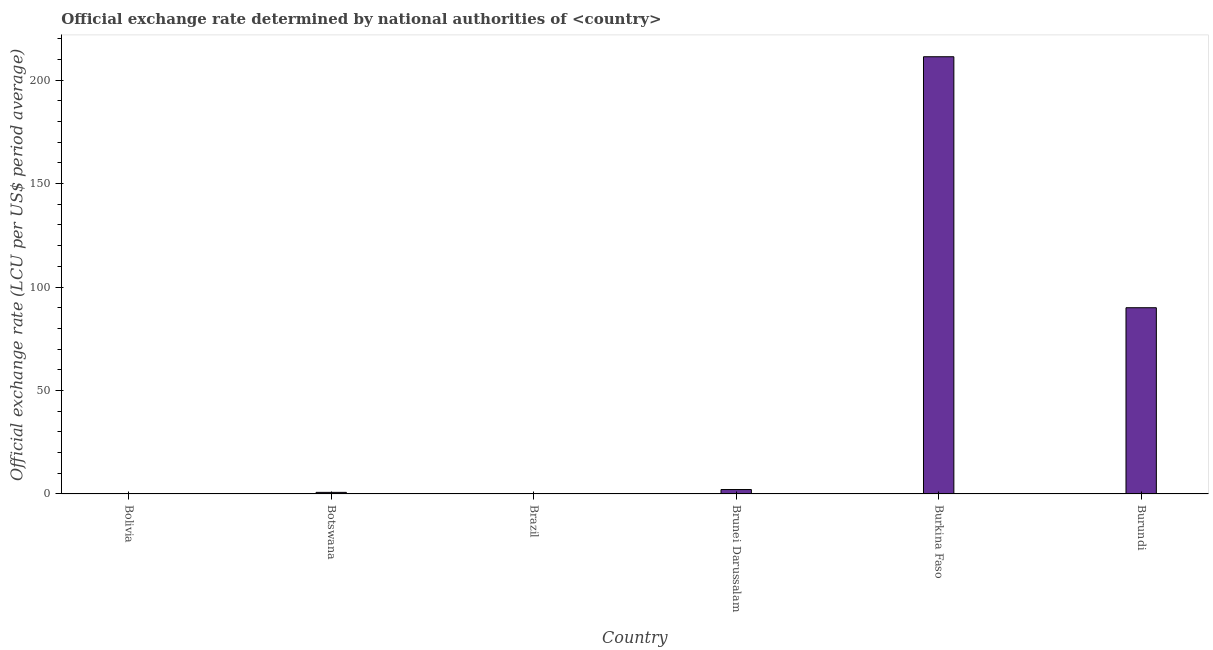Does the graph contain any zero values?
Ensure brevity in your answer.  No. Does the graph contain grids?
Your answer should be very brief. No. What is the title of the graph?
Ensure brevity in your answer.  Official exchange rate determined by national authorities of <country>. What is the label or title of the X-axis?
Provide a short and direct response. Country. What is the label or title of the Y-axis?
Your answer should be very brief. Official exchange rate (LCU per US$ period average). What is the official exchange rate in Brunei Darussalam?
Provide a succinct answer. 2.14. Across all countries, what is the maximum official exchange rate?
Your answer should be very brief. 211.28. Across all countries, what is the minimum official exchange rate?
Offer a very short reply. 2.28123189244443e-11. In which country was the official exchange rate maximum?
Provide a short and direct response. Burkina Faso. In which country was the official exchange rate minimum?
Your answer should be very brief. Brazil. What is the sum of the official exchange rate?
Offer a terse response. 304.2. What is the difference between the official exchange rate in Bolivia and Brunei Darussalam?
Your answer should be compact. -2.14. What is the average official exchange rate per country?
Your answer should be compact. 50.7. What is the median official exchange rate?
Your answer should be very brief. 1.46. In how many countries, is the official exchange rate greater than 140 ?
Your answer should be very brief. 1. What is the ratio of the official exchange rate in Burkina Faso to that in Burundi?
Your response must be concise. 2.35. What is the difference between the highest and the second highest official exchange rate?
Offer a very short reply. 121.28. Is the sum of the official exchange rate in Bolivia and Brunei Darussalam greater than the maximum official exchange rate across all countries?
Provide a succinct answer. No. What is the difference between the highest and the lowest official exchange rate?
Your answer should be very brief. 211.28. In how many countries, is the official exchange rate greater than the average official exchange rate taken over all countries?
Offer a terse response. 2. What is the Official exchange rate (LCU per US$ period average) of Bolivia?
Ensure brevity in your answer.  2.452e-5. What is the Official exchange rate (LCU per US$ period average) of Botswana?
Provide a short and direct response. 0.78. What is the Official exchange rate (LCU per US$ period average) in Brazil?
Offer a terse response. 2.28123189244443e-11. What is the Official exchange rate (LCU per US$ period average) in Brunei Darussalam?
Provide a short and direct response. 2.14. What is the Official exchange rate (LCU per US$ period average) of Burkina Faso?
Keep it short and to the point. 211.28. What is the difference between the Official exchange rate (LCU per US$ period average) in Bolivia and Botswana?
Your response must be concise. -0.78. What is the difference between the Official exchange rate (LCU per US$ period average) in Bolivia and Brazil?
Give a very brief answer. 2e-5. What is the difference between the Official exchange rate (LCU per US$ period average) in Bolivia and Brunei Darussalam?
Make the answer very short. -2.14. What is the difference between the Official exchange rate (LCU per US$ period average) in Bolivia and Burkina Faso?
Your response must be concise. -211.28. What is the difference between the Official exchange rate (LCU per US$ period average) in Bolivia and Burundi?
Provide a succinct answer. -90. What is the difference between the Official exchange rate (LCU per US$ period average) in Botswana and Brazil?
Offer a very short reply. 0.78. What is the difference between the Official exchange rate (LCU per US$ period average) in Botswana and Brunei Darussalam?
Offer a terse response. -1.36. What is the difference between the Official exchange rate (LCU per US$ period average) in Botswana and Burkina Faso?
Offer a very short reply. -210.5. What is the difference between the Official exchange rate (LCU per US$ period average) in Botswana and Burundi?
Give a very brief answer. -89.22. What is the difference between the Official exchange rate (LCU per US$ period average) in Brazil and Brunei Darussalam?
Your answer should be very brief. -2.14. What is the difference between the Official exchange rate (LCU per US$ period average) in Brazil and Burkina Faso?
Give a very brief answer. -211.28. What is the difference between the Official exchange rate (LCU per US$ period average) in Brazil and Burundi?
Make the answer very short. -90. What is the difference between the Official exchange rate (LCU per US$ period average) in Brunei Darussalam and Burkina Faso?
Ensure brevity in your answer.  -209.14. What is the difference between the Official exchange rate (LCU per US$ period average) in Brunei Darussalam and Burundi?
Provide a short and direct response. -87.86. What is the difference between the Official exchange rate (LCU per US$ period average) in Burkina Faso and Burundi?
Make the answer very short. 121.28. What is the ratio of the Official exchange rate (LCU per US$ period average) in Bolivia to that in Botswana?
Provide a short and direct response. 0. What is the ratio of the Official exchange rate (LCU per US$ period average) in Bolivia to that in Brazil?
Ensure brevity in your answer.  1.07e+06. What is the ratio of the Official exchange rate (LCU per US$ period average) in Bolivia to that in Burundi?
Make the answer very short. 0. What is the ratio of the Official exchange rate (LCU per US$ period average) in Botswana to that in Brazil?
Offer a terse response. 3.41e+1. What is the ratio of the Official exchange rate (LCU per US$ period average) in Botswana to that in Brunei Darussalam?
Your answer should be compact. 0.36. What is the ratio of the Official exchange rate (LCU per US$ period average) in Botswana to that in Burkina Faso?
Give a very brief answer. 0. What is the ratio of the Official exchange rate (LCU per US$ period average) in Botswana to that in Burundi?
Your answer should be very brief. 0.01. What is the ratio of the Official exchange rate (LCU per US$ period average) in Brazil to that in Brunei Darussalam?
Your answer should be compact. 0. What is the ratio of the Official exchange rate (LCU per US$ period average) in Brunei Darussalam to that in Burundi?
Keep it short and to the point. 0.02. What is the ratio of the Official exchange rate (LCU per US$ period average) in Burkina Faso to that in Burundi?
Provide a succinct answer. 2.35. 